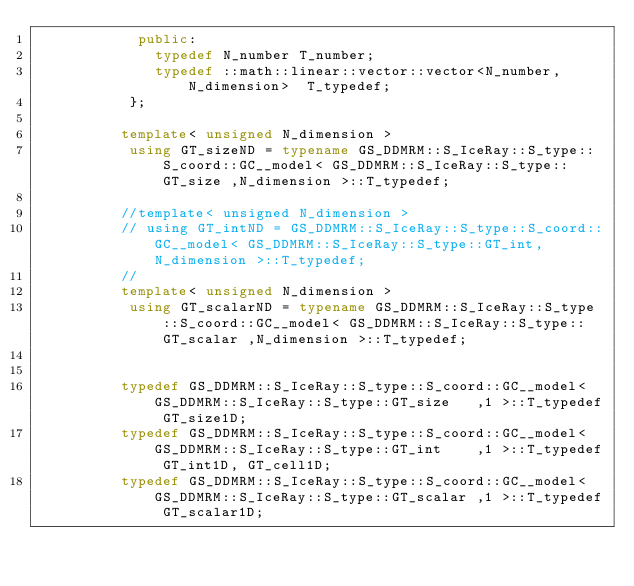Convert code to text. <code><loc_0><loc_0><loc_500><loc_500><_C++_>            public:
              typedef N_number T_number;
              typedef ::math::linear::vector::vector<N_number, N_dimension>  T_typedef;
           };

          template< unsigned N_dimension >
           using GT_sizeND = typename GS_DDMRM::S_IceRay::S_type::S_coord::GC__model< GS_DDMRM::S_IceRay::S_type::GT_size ,N_dimension >::T_typedef;

          //template< unsigned N_dimension >
          // using GT_intND = GS_DDMRM::S_IceRay::S_type::S_coord::GC__model< GS_DDMRM::S_IceRay::S_type::GT_int,N_dimension >::T_typedef;
          //
          template< unsigned N_dimension >
           using GT_scalarND = typename GS_DDMRM::S_IceRay::S_type::S_coord::GC__model< GS_DDMRM::S_IceRay::S_type::GT_scalar ,N_dimension >::T_typedef;


          typedef GS_DDMRM::S_IceRay::S_type::S_coord::GC__model< GS_DDMRM::S_IceRay::S_type::GT_size   ,1 >::T_typedef GT_size1D;
          typedef GS_DDMRM::S_IceRay::S_type::S_coord::GC__model< GS_DDMRM::S_IceRay::S_type::GT_int    ,1 >::T_typedef GT_int1D, GT_cell1D;
          typedef GS_DDMRM::S_IceRay::S_type::S_coord::GC__model< GS_DDMRM::S_IceRay::S_type::GT_scalar ,1 >::T_typedef GT_scalar1D;
</code> 